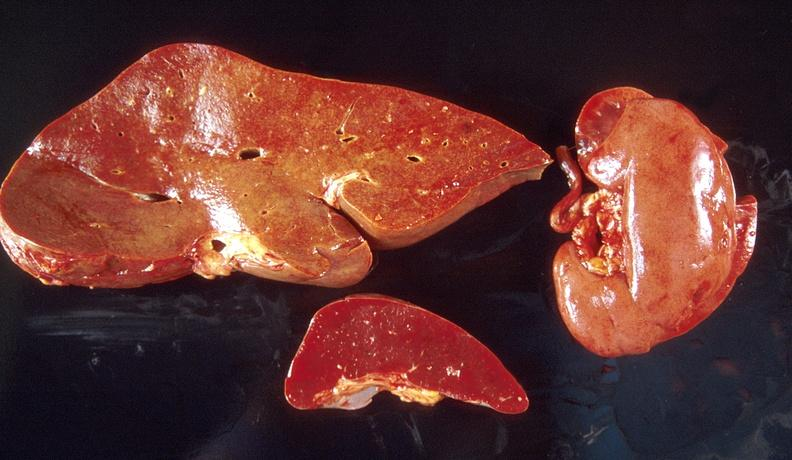what does this image show?
Answer the question using a single word or phrase. Amyloid 